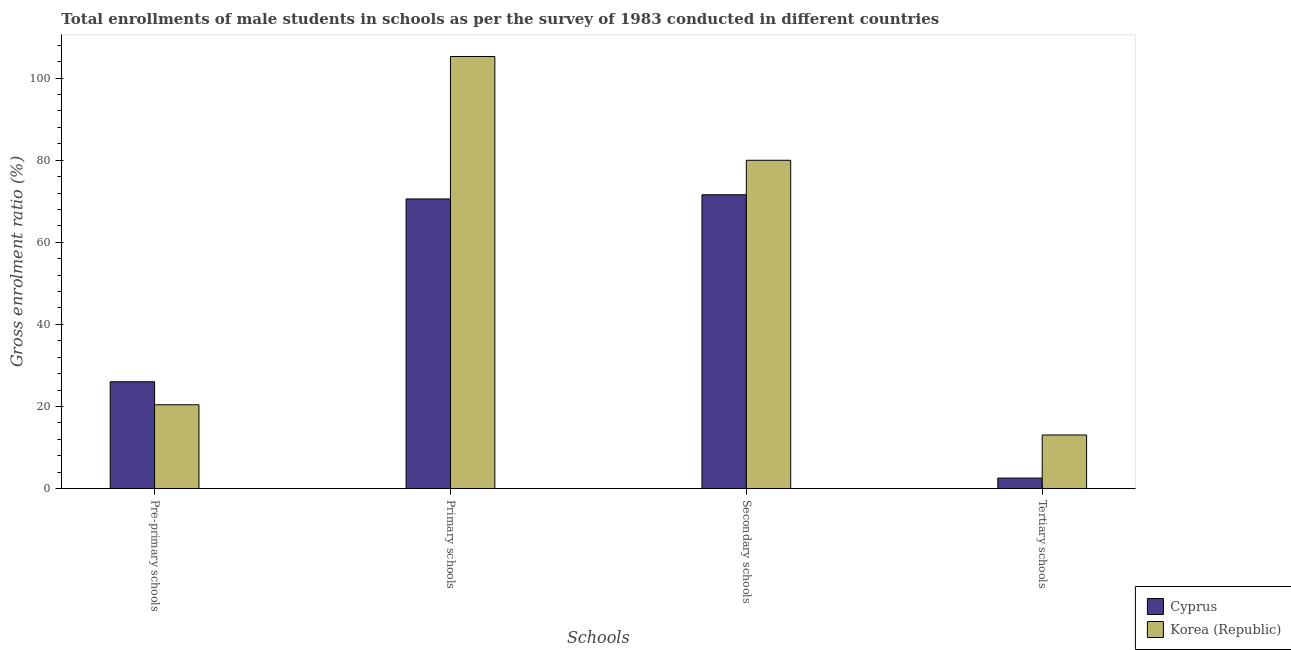Are the number of bars per tick equal to the number of legend labels?
Provide a succinct answer. Yes. Are the number of bars on each tick of the X-axis equal?
Your answer should be compact. Yes. How many bars are there on the 3rd tick from the right?
Ensure brevity in your answer.  2. What is the label of the 1st group of bars from the left?
Ensure brevity in your answer.  Pre-primary schools. What is the gross enrolment ratio(male) in pre-primary schools in Korea (Republic)?
Offer a terse response. 20.44. Across all countries, what is the maximum gross enrolment ratio(male) in pre-primary schools?
Offer a terse response. 26.04. Across all countries, what is the minimum gross enrolment ratio(male) in tertiary schools?
Offer a very short reply. 2.58. In which country was the gross enrolment ratio(male) in primary schools minimum?
Your answer should be compact. Cyprus. What is the total gross enrolment ratio(male) in pre-primary schools in the graph?
Keep it short and to the point. 46.47. What is the difference between the gross enrolment ratio(male) in primary schools in Korea (Republic) and that in Cyprus?
Give a very brief answer. 34.69. What is the difference between the gross enrolment ratio(male) in tertiary schools in Korea (Republic) and the gross enrolment ratio(male) in secondary schools in Cyprus?
Offer a very short reply. -58.5. What is the average gross enrolment ratio(male) in secondary schools per country?
Offer a very short reply. 75.77. What is the difference between the gross enrolment ratio(male) in primary schools and gross enrolment ratio(male) in tertiary schools in Cyprus?
Keep it short and to the point. 67.97. In how many countries, is the gross enrolment ratio(male) in primary schools greater than 100 %?
Give a very brief answer. 1. What is the ratio of the gross enrolment ratio(male) in pre-primary schools in Cyprus to that in Korea (Republic)?
Offer a terse response. 1.27. Is the difference between the gross enrolment ratio(male) in primary schools in Korea (Republic) and Cyprus greater than the difference between the gross enrolment ratio(male) in pre-primary schools in Korea (Republic) and Cyprus?
Ensure brevity in your answer.  Yes. What is the difference between the highest and the second highest gross enrolment ratio(male) in pre-primary schools?
Provide a succinct answer. 5.6. What is the difference between the highest and the lowest gross enrolment ratio(male) in primary schools?
Your answer should be very brief. 34.69. In how many countries, is the gross enrolment ratio(male) in tertiary schools greater than the average gross enrolment ratio(male) in tertiary schools taken over all countries?
Make the answer very short. 1. What does the 1st bar from the right in Primary schools represents?
Your response must be concise. Korea (Republic). Is it the case that in every country, the sum of the gross enrolment ratio(male) in pre-primary schools and gross enrolment ratio(male) in primary schools is greater than the gross enrolment ratio(male) in secondary schools?
Keep it short and to the point. Yes. How many bars are there?
Ensure brevity in your answer.  8. Are all the bars in the graph horizontal?
Make the answer very short. No. How many countries are there in the graph?
Your answer should be compact. 2. Does the graph contain grids?
Your response must be concise. No. Where does the legend appear in the graph?
Ensure brevity in your answer.  Bottom right. What is the title of the graph?
Provide a succinct answer. Total enrollments of male students in schools as per the survey of 1983 conducted in different countries. What is the label or title of the X-axis?
Ensure brevity in your answer.  Schools. What is the label or title of the Y-axis?
Your answer should be compact. Gross enrolment ratio (%). What is the Gross enrolment ratio (%) in Cyprus in Pre-primary schools?
Keep it short and to the point. 26.04. What is the Gross enrolment ratio (%) of Korea (Republic) in Pre-primary schools?
Make the answer very short. 20.44. What is the Gross enrolment ratio (%) of Cyprus in Primary schools?
Give a very brief answer. 70.55. What is the Gross enrolment ratio (%) in Korea (Republic) in Primary schools?
Your answer should be very brief. 105.25. What is the Gross enrolment ratio (%) in Cyprus in Secondary schools?
Keep it short and to the point. 71.57. What is the Gross enrolment ratio (%) in Korea (Republic) in Secondary schools?
Provide a short and direct response. 79.97. What is the Gross enrolment ratio (%) in Cyprus in Tertiary schools?
Give a very brief answer. 2.58. What is the Gross enrolment ratio (%) in Korea (Republic) in Tertiary schools?
Your response must be concise. 13.08. Across all Schools, what is the maximum Gross enrolment ratio (%) in Cyprus?
Your answer should be compact. 71.57. Across all Schools, what is the maximum Gross enrolment ratio (%) of Korea (Republic)?
Your response must be concise. 105.25. Across all Schools, what is the minimum Gross enrolment ratio (%) in Cyprus?
Your response must be concise. 2.58. Across all Schools, what is the minimum Gross enrolment ratio (%) of Korea (Republic)?
Give a very brief answer. 13.08. What is the total Gross enrolment ratio (%) of Cyprus in the graph?
Your response must be concise. 170.74. What is the total Gross enrolment ratio (%) of Korea (Republic) in the graph?
Offer a very short reply. 218.73. What is the difference between the Gross enrolment ratio (%) in Cyprus in Pre-primary schools and that in Primary schools?
Offer a terse response. -44.52. What is the difference between the Gross enrolment ratio (%) of Korea (Republic) in Pre-primary schools and that in Primary schools?
Keep it short and to the point. -84.81. What is the difference between the Gross enrolment ratio (%) of Cyprus in Pre-primary schools and that in Secondary schools?
Your answer should be very brief. -45.53. What is the difference between the Gross enrolment ratio (%) of Korea (Republic) in Pre-primary schools and that in Secondary schools?
Offer a terse response. -59.53. What is the difference between the Gross enrolment ratio (%) in Cyprus in Pre-primary schools and that in Tertiary schools?
Offer a very short reply. 23.46. What is the difference between the Gross enrolment ratio (%) of Korea (Republic) in Pre-primary schools and that in Tertiary schools?
Provide a succinct answer. 7.36. What is the difference between the Gross enrolment ratio (%) in Cyprus in Primary schools and that in Secondary schools?
Offer a terse response. -1.02. What is the difference between the Gross enrolment ratio (%) of Korea (Republic) in Primary schools and that in Secondary schools?
Offer a terse response. 25.28. What is the difference between the Gross enrolment ratio (%) of Cyprus in Primary schools and that in Tertiary schools?
Provide a succinct answer. 67.97. What is the difference between the Gross enrolment ratio (%) in Korea (Republic) in Primary schools and that in Tertiary schools?
Offer a very short reply. 92.17. What is the difference between the Gross enrolment ratio (%) in Cyprus in Secondary schools and that in Tertiary schools?
Offer a very short reply. 68.99. What is the difference between the Gross enrolment ratio (%) of Korea (Republic) in Secondary schools and that in Tertiary schools?
Give a very brief answer. 66.89. What is the difference between the Gross enrolment ratio (%) in Cyprus in Pre-primary schools and the Gross enrolment ratio (%) in Korea (Republic) in Primary schools?
Offer a very short reply. -79.21. What is the difference between the Gross enrolment ratio (%) in Cyprus in Pre-primary schools and the Gross enrolment ratio (%) in Korea (Republic) in Secondary schools?
Ensure brevity in your answer.  -53.93. What is the difference between the Gross enrolment ratio (%) of Cyprus in Pre-primary schools and the Gross enrolment ratio (%) of Korea (Republic) in Tertiary schools?
Keep it short and to the point. 12.96. What is the difference between the Gross enrolment ratio (%) of Cyprus in Primary schools and the Gross enrolment ratio (%) of Korea (Republic) in Secondary schools?
Your answer should be compact. -9.42. What is the difference between the Gross enrolment ratio (%) in Cyprus in Primary schools and the Gross enrolment ratio (%) in Korea (Republic) in Tertiary schools?
Offer a terse response. 57.48. What is the difference between the Gross enrolment ratio (%) of Cyprus in Secondary schools and the Gross enrolment ratio (%) of Korea (Republic) in Tertiary schools?
Your answer should be very brief. 58.5. What is the average Gross enrolment ratio (%) of Cyprus per Schools?
Make the answer very short. 42.68. What is the average Gross enrolment ratio (%) in Korea (Republic) per Schools?
Your answer should be very brief. 54.68. What is the difference between the Gross enrolment ratio (%) in Cyprus and Gross enrolment ratio (%) in Korea (Republic) in Pre-primary schools?
Make the answer very short. 5.6. What is the difference between the Gross enrolment ratio (%) of Cyprus and Gross enrolment ratio (%) of Korea (Republic) in Primary schools?
Offer a terse response. -34.69. What is the difference between the Gross enrolment ratio (%) of Cyprus and Gross enrolment ratio (%) of Korea (Republic) in Secondary schools?
Your answer should be very brief. -8.4. What is the difference between the Gross enrolment ratio (%) in Cyprus and Gross enrolment ratio (%) in Korea (Republic) in Tertiary schools?
Make the answer very short. -10.5. What is the ratio of the Gross enrolment ratio (%) of Cyprus in Pre-primary schools to that in Primary schools?
Keep it short and to the point. 0.37. What is the ratio of the Gross enrolment ratio (%) of Korea (Republic) in Pre-primary schools to that in Primary schools?
Ensure brevity in your answer.  0.19. What is the ratio of the Gross enrolment ratio (%) in Cyprus in Pre-primary schools to that in Secondary schools?
Make the answer very short. 0.36. What is the ratio of the Gross enrolment ratio (%) in Korea (Republic) in Pre-primary schools to that in Secondary schools?
Offer a very short reply. 0.26. What is the ratio of the Gross enrolment ratio (%) in Cyprus in Pre-primary schools to that in Tertiary schools?
Ensure brevity in your answer.  10.1. What is the ratio of the Gross enrolment ratio (%) of Korea (Republic) in Pre-primary schools to that in Tertiary schools?
Offer a terse response. 1.56. What is the ratio of the Gross enrolment ratio (%) in Cyprus in Primary schools to that in Secondary schools?
Ensure brevity in your answer.  0.99. What is the ratio of the Gross enrolment ratio (%) in Korea (Republic) in Primary schools to that in Secondary schools?
Provide a succinct answer. 1.32. What is the ratio of the Gross enrolment ratio (%) of Cyprus in Primary schools to that in Tertiary schools?
Offer a terse response. 27.36. What is the ratio of the Gross enrolment ratio (%) in Korea (Republic) in Primary schools to that in Tertiary schools?
Offer a terse response. 8.05. What is the ratio of the Gross enrolment ratio (%) of Cyprus in Secondary schools to that in Tertiary schools?
Give a very brief answer. 27.75. What is the ratio of the Gross enrolment ratio (%) of Korea (Republic) in Secondary schools to that in Tertiary schools?
Give a very brief answer. 6.12. What is the difference between the highest and the second highest Gross enrolment ratio (%) of Korea (Republic)?
Give a very brief answer. 25.28. What is the difference between the highest and the lowest Gross enrolment ratio (%) of Cyprus?
Make the answer very short. 68.99. What is the difference between the highest and the lowest Gross enrolment ratio (%) of Korea (Republic)?
Ensure brevity in your answer.  92.17. 